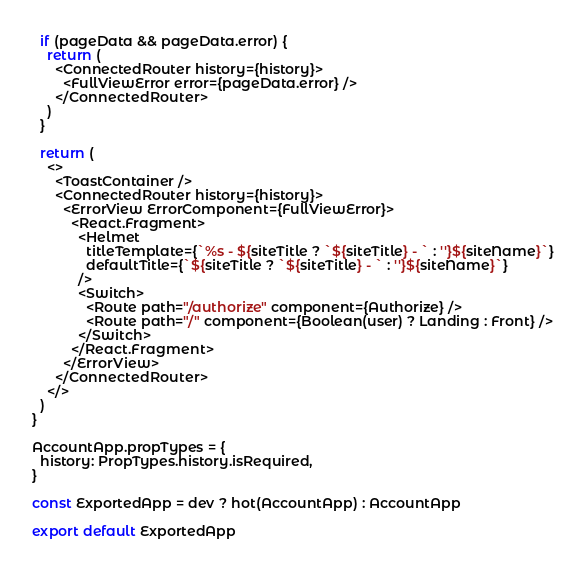Convert code to text. <code><loc_0><loc_0><loc_500><loc_500><_JavaScript_>
  if (pageData && pageData.error) {
    return (
      <ConnectedRouter history={history}>
        <FullViewError error={pageData.error} />
      </ConnectedRouter>
    )
  }

  return (
    <>
      <ToastContainer />
      <ConnectedRouter history={history}>
        <ErrorView ErrorComponent={FullViewError}>
          <React.Fragment>
            <Helmet
              titleTemplate={`%s - ${siteTitle ? `${siteTitle} - ` : ''}${siteName}`}
              defaultTitle={`${siteTitle ? `${siteTitle} - ` : ''}${siteName}`}
            />
            <Switch>
              <Route path="/authorize" component={Authorize} />
              <Route path="/" component={Boolean(user) ? Landing : Front} />
            </Switch>
          </React.Fragment>
        </ErrorView>
      </ConnectedRouter>
    </>
  )
}

AccountApp.propTypes = {
  history: PropTypes.history.isRequired,
}

const ExportedApp = dev ? hot(AccountApp) : AccountApp

export default ExportedApp
</code> 